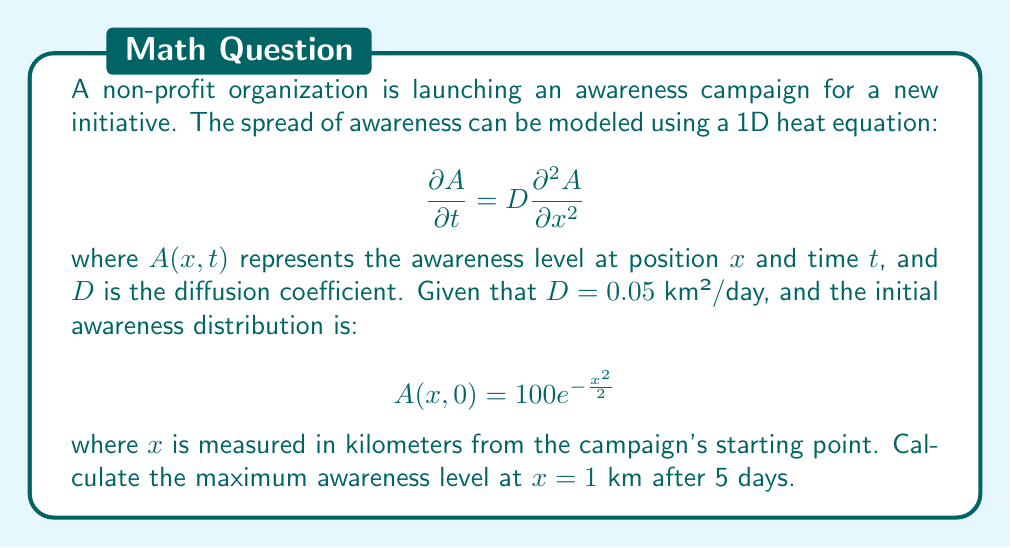Show me your answer to this math problem. To solve this problem, we need to use the solution to the 1D heat equation with an initial Gaussian distribution. The solution is given by:

$$A(x,t) = \frac{100}{\sqrt{1+2Dt}} \exp\left(-\frac{x^2}{2(1+2Dt)}\right)$$

Let's follow these steps:

1. Substitute the given values:
   $D = 0.05$ km²/day
   $x = 1$ km
   $t = 5$ days

2. Calculate $1+2Dt$:
   $1+2Dt = 1 + 2(0.05)(5) = 1.5$

3. Substitute into the solution equation:

   $$A(1,5) = \frac{100}{\sqrt{1.5}} \exp\left(-\frac{1^2}{2(1.5)}\right)$$

4. Simplify:
   $$A(1,5) = \frac{100}{\sqrt{1.5}} \exp\left(-\frac{1}{3}\right)$$

5. Calculate the result:
   $$A(1,5) = 81.65 \cdot 0.7165 = 58.50$$

Therefore, the maximum awareness level at $x = 1$ km after 5 days is approximately 58.50 units.
Answer: 58.50 